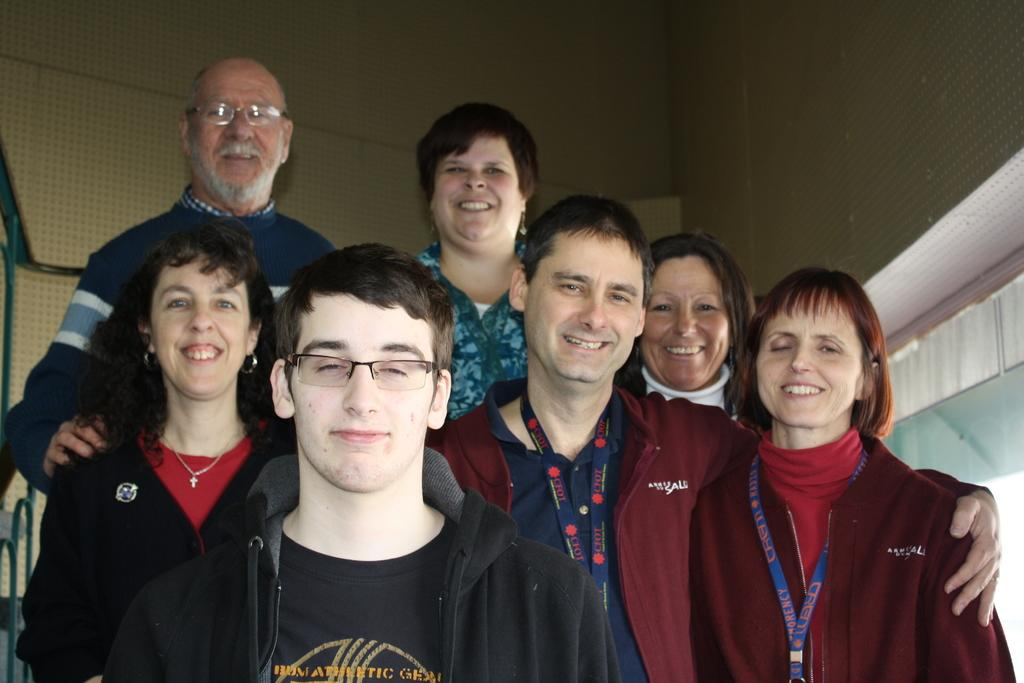What types of people are present in the image? There are men and women in the image. What are the men and women doing in the image? The men and women are standing in the image. What expressions do the men and women have in the image? The men and women are smiling in the image. What type of fold can be seen in the image? There is no fold present in the image; it features men and women standing and smiling. What behavior is exhibited by the hose in the image? There is no hose present in the image, so it is not possible to determine its behavior. 